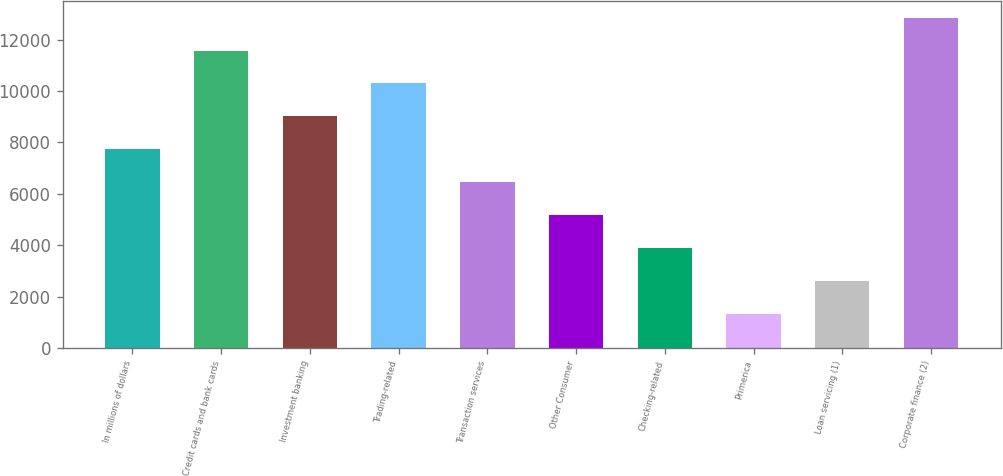Convert chart. <chart><loc_0><loc_0><loc_500><loc_500><bar_chart><fcel>In millions of dollars<fcel>Credit cards and bank cards<fcel>Investment banking<fcel>Trading-related<fcel>Transaction services<fcel>Other Consumer<fcel>Checking-related<fcel>Primerica<fcel>Loan servicing (1)<fcel>Corporate finance (2)<nl><fcel>7734.6<fcel>11574.9<fcel>9014.7<fcel>10294.8<fcel>6454.5<fcel>5174.4<fcel>3894.3<fcel>1334.1<fcel>2614.2<fcel>12855<nl></chart> 